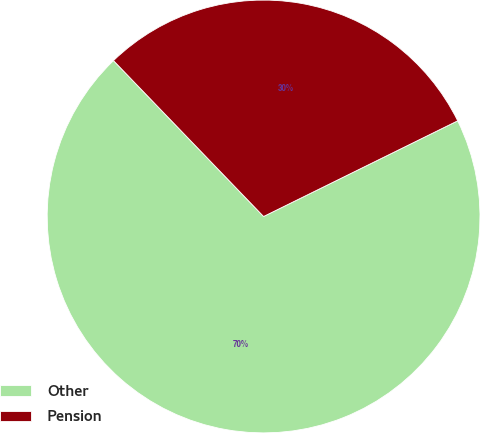<chart> <loc_0><loc_0><loc_500><loc_500><pie_chart><fcel>Other<fcel>Pension<nl><fcel>70.09%<fcel>29.91%<nl></chart> 